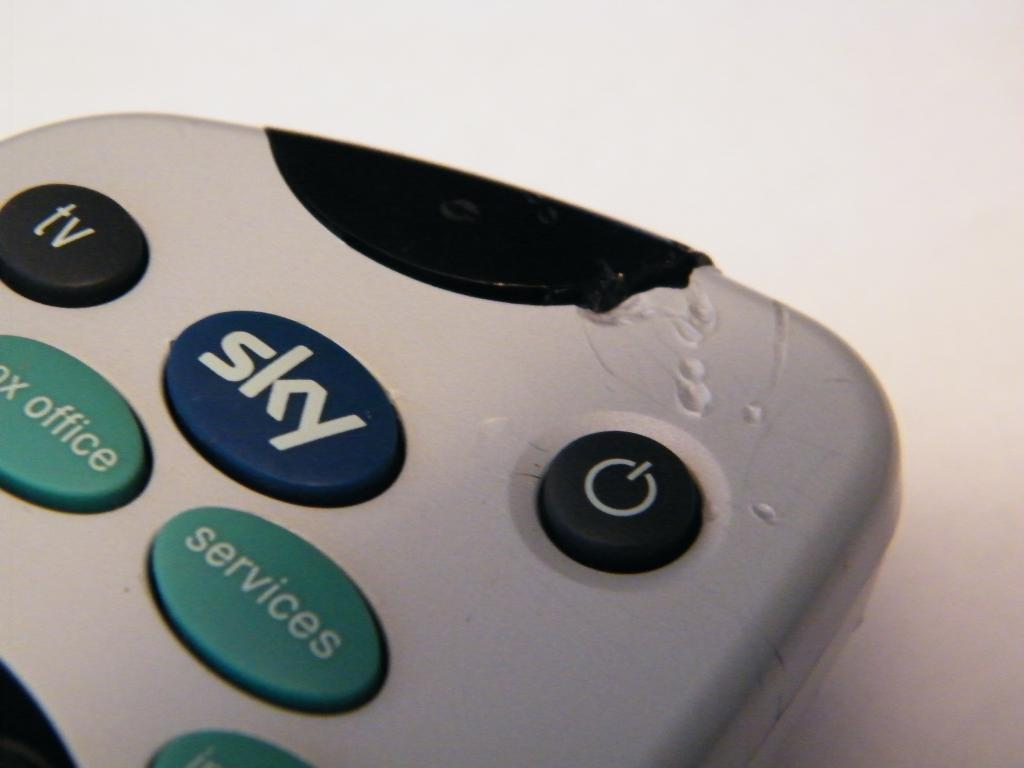Provide a one-sentence caption for the provided image. The remote control was chewed on but still worked. 